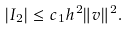<formula> <loc_0><loc_0><loc_500><loc_500>| I _ { 2 } | \leq c _ { 1 } h ^ { 2 } \| v \| ^ { 2 } .</formula> 